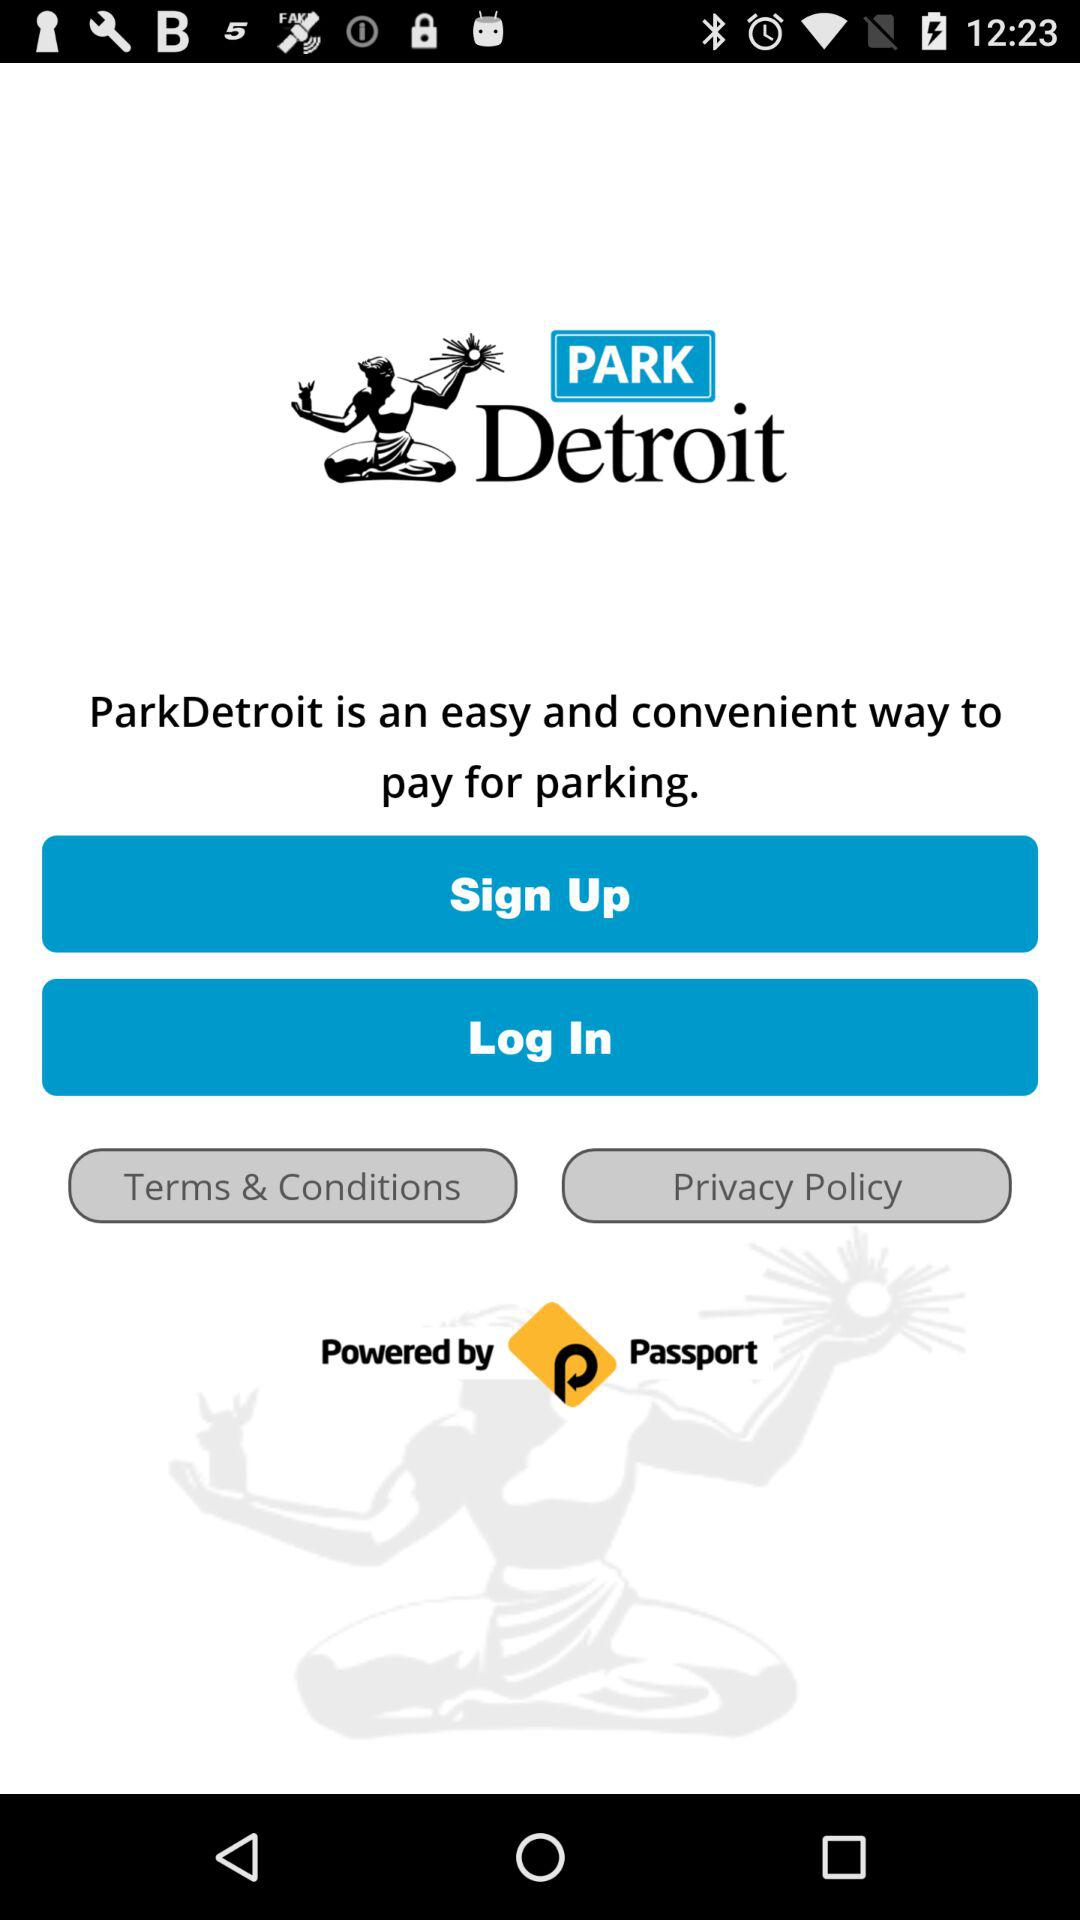How much does parking cost?
When the provided information is insufficient, respond with <no answer>. <no answer> 